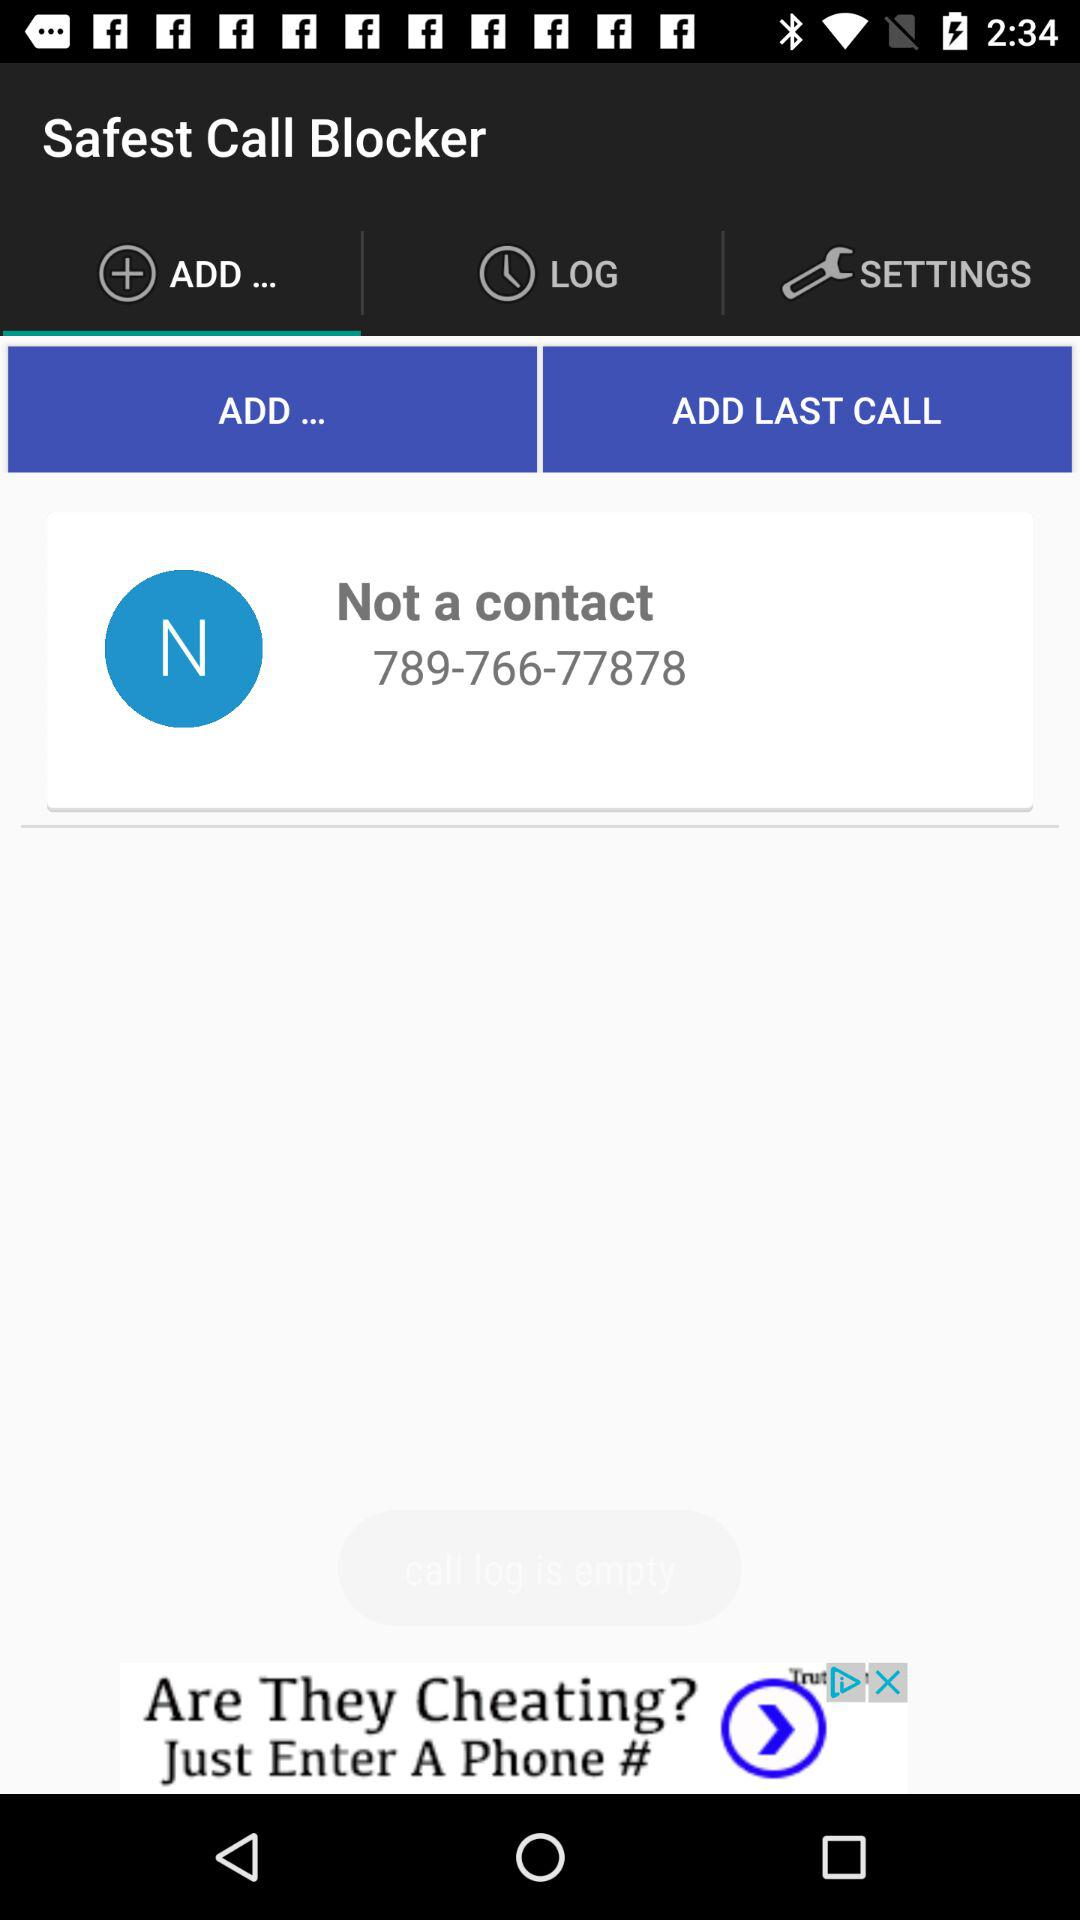What is the phone number added to the call blocker? The phone number added is 789-766-77878. 